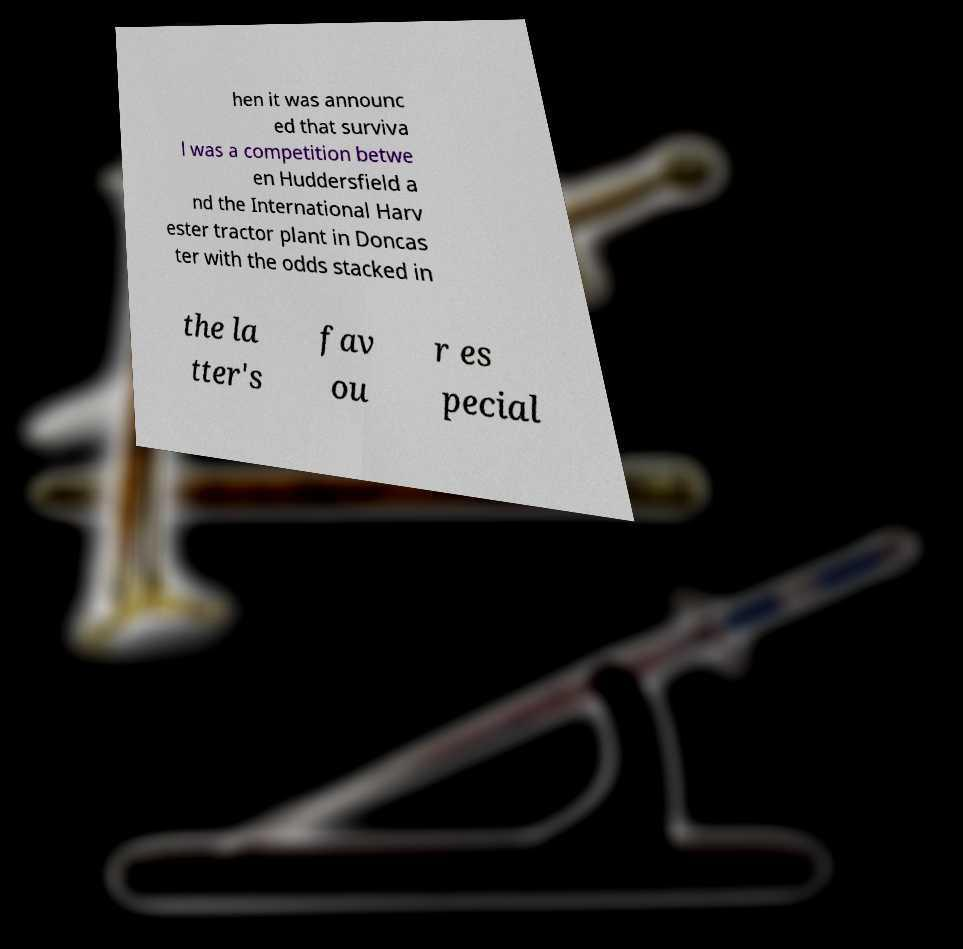Can you read and provide the text displayed in the image?This photo seems to have some interesting text. Can you extract and type it out for me? hen it was announc ed that surviva l was a competition betwe en Huddersfield a nd the International Harv ester tractor plant in Doncas ter with the odds stacked in the la tter's fav ou r es pecial 